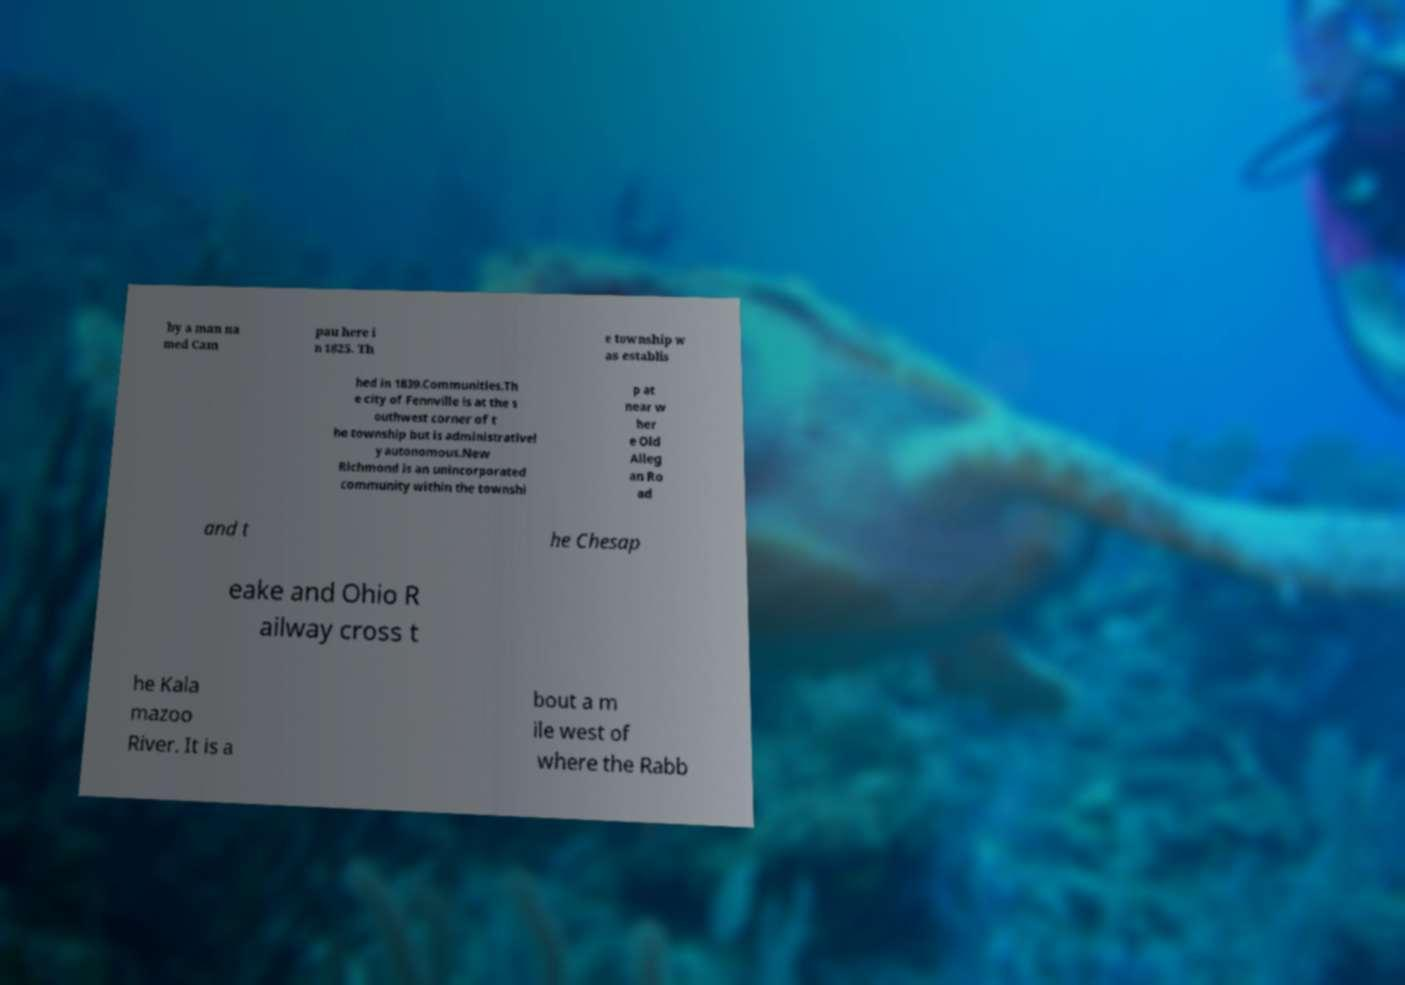Please identify and transcribe the text found in this image. by a man na med Cam pau here i n 1825. Th e township w as establis hed in 1839.Communities.Th e city of Fennville is at the s outhwest corner of t he township but is administrativel y autonomous.New Richmond is an unincorporated community within the townshi p at near w her e Old Alleg an Ro ad and t he Chesap eake and Ohio R ailway cross t he Kala mazoo River. It is a bout a m ile west of where the Rabb 